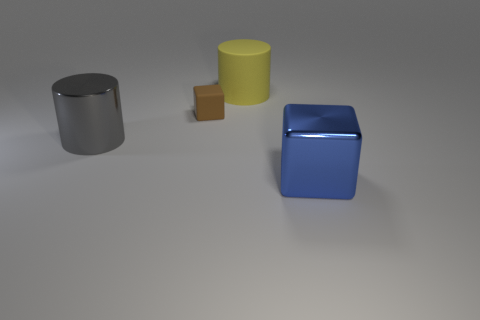Subtract all blue blocks. How many blocks are left? 1 Add 1 tiny brown shiny spheres. How many objects exist? 5 Subtract 0 brown spheres. How many objects are left? 4 Subtract all small brown objects. Subtract all large matte objects. How many objects are left? 2 Add 1 blue metallic objects. How many blue metallic objects are left? 2 Add 1 small objects. How many small objects exist? 2 